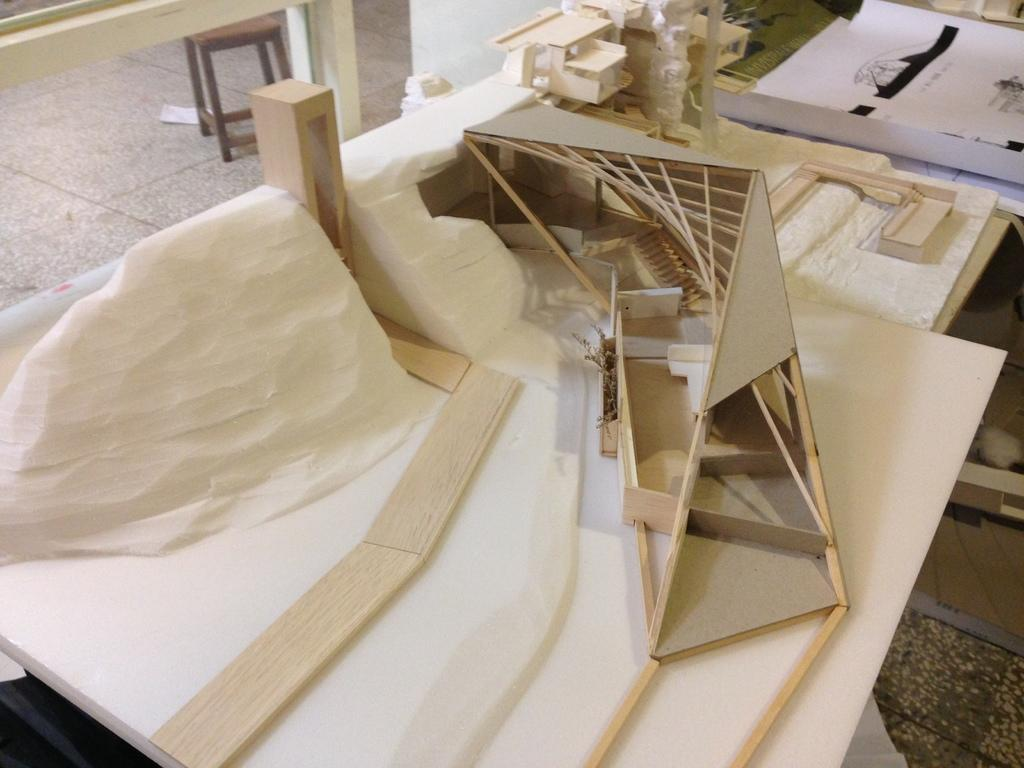What is located on the platform in the image? The facts do not specify what objects are on the platform. What type of furniture is on the floor in the background of the image? There is a stool on the floor in the background of the image. What can be seen on the wall in the background of the image? There is a chart visible on the wall in the background of the image. What else can be seen in the background of the image? There are other unspecified objects in the background of the image. What type of jar is sitting on the throne in the image? There is no throne or jar present in the image. 